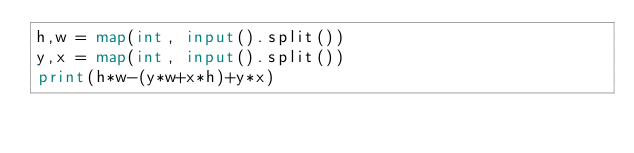<code> <loc_0><loc_0><loc_500><loc_500><_Python_>h,w = map(int, input().split())
y,x = map(int, input().split())
print(h*w-(y*w+x*h)+y*x)</code> 